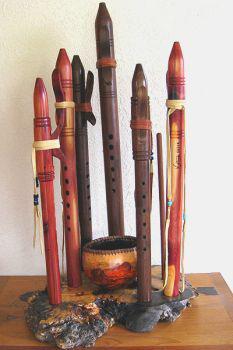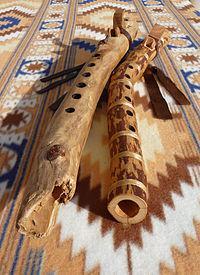The first image is the image on the left, the second image is the image on the right. Given the left and right images, does the statement "There are less than three instruments in the right image." hold true? Answer yes or no. Yes. The first image is the image on the left, the second image is the image on the right. For the images displayed, is the sentence "The right image shows a rustic curved wooden flute with brown straps at its top, and it is displayed end-first." factually correct? Answer yes or no. Yes. 